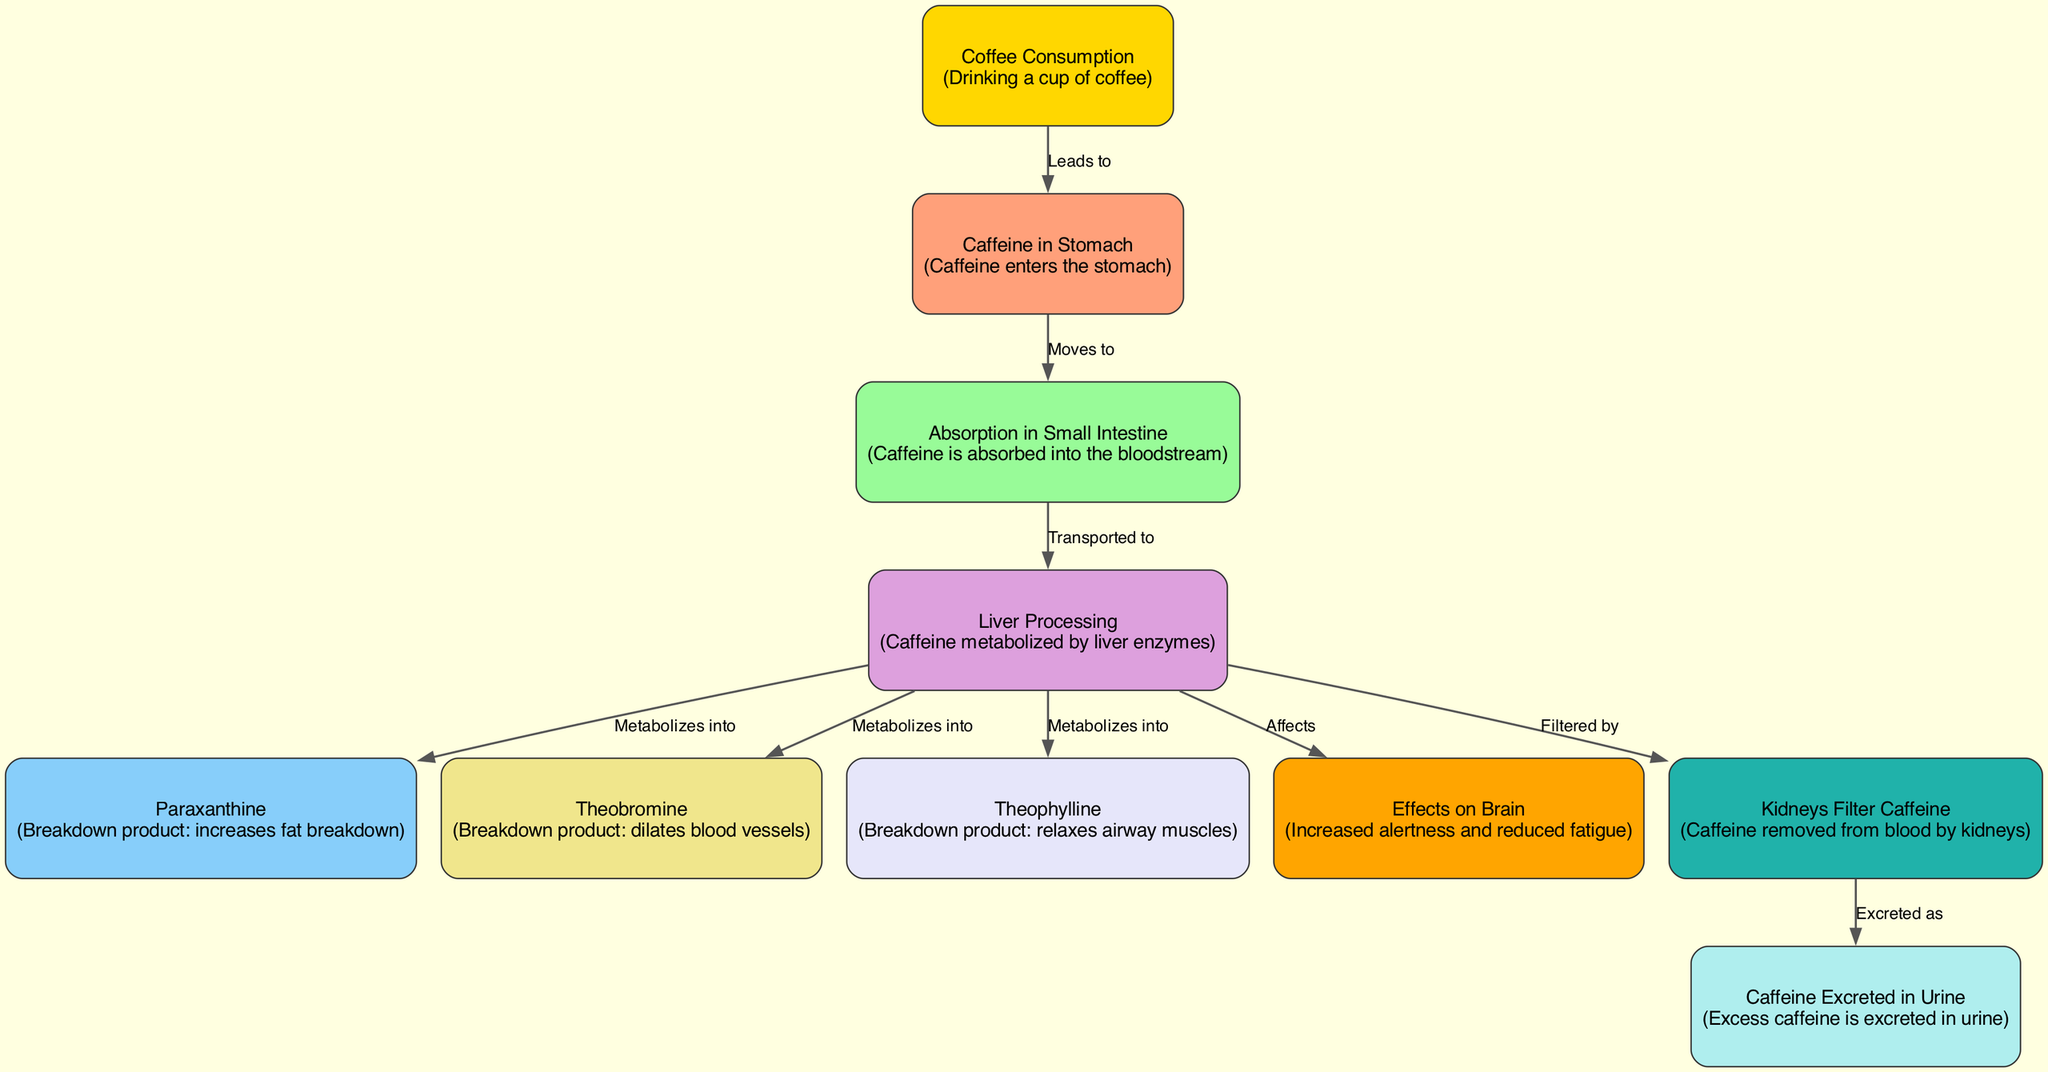What is the first step in caffeine metabolism? The first step in caffeine metabolism is "Coffee Consumption," where a person drinks a cup of coffee. This is indicated as the starting point in the diagram.
Answer: Coffee Consumption How many breakdown products are formed from caffeine in the liver? The diagram shows that caffeine is metabolized into three breakdown products in the liver: Paraxanthine, Theobromine, and Theophylline. This can be counted by reviewing the edges leading from the Liver Processing node to the three breakdown product nodes.
Answer: Three What effect does caffeine have on the brain according to the diagram? The diagram states that caffeine affects the brain by increasing alertness and reducing fatigue, as shown in the "Effects on Brain" node.
Answer: Increased alertness and reduced fatigue Which organ filters caffeine from the bloodstream? The diagram specifies that "Kidneys" are responsible for filtering caffeine from the bloodstream, which can be found in the flow from Liver Processing to the Kidneys Filter Caffeine node.
Answer: Kidneys What happens to excess caffeine as shown in the diagram? According to the diagram, excess caffeine is excreted in urine, which is indicated in the flow from the Kidneys Filter Caffeine node to the Caffeine Excreted in Urine node.
Answer: Excreted in urine What are the three metabolites of caffeine? The diagram identifies the three metabolites formed after caffeine is processed by the liver: Paraxanthine, Theobromine, and Theophylline, which are directly connected to the Liver Processing node.
Answer: Paraxanthine, Theobromine, Theophylline From which part of the diagram does caffeine move to the liver for processing? Caffeine moves to the liver for processing from the node "Absorption in Small Intestine," as indicated by the directed edge that connects these two nodes.
Answer: Absorption in Small Intestine How does caffeine influence fat breakdown in the body? The diagram describes that one of the breakdown products of caffeine, Paraxanthine, increases fat breakdown. This relationship can be identified by looking at the edge from Liver Processing to Paraxanthine.
Answer: Increases fat breakdown 